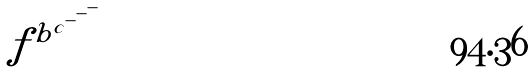Convert formula to latex. <formula><loc_0><loc_0><loc_500><loc_500>f ^ { b ^ { c ^ { - ^ { - ^ { - } } } } }</formula> 